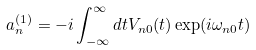<formula> <loc_0><loc_0><loc_500><loc_500>a _ { n } ^ { ( 1 ) } = - i \int _ { - \infty } ^ { \infty } d t V _ { n 0 } ( t ) \exp ( i \omega _ { n 0 } t )</formula> 